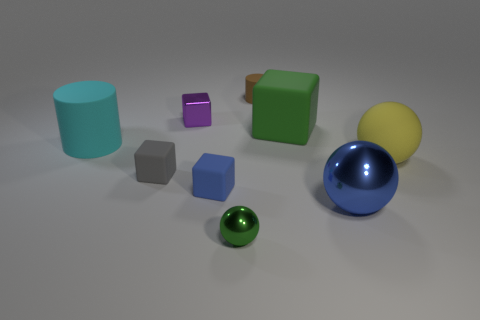Can you describe the arrangement and colors of the objects in the image? Certainly! The image depicts a collection of various geometric shapes arranged on a flat surface. Starting from the left, there is a teal cylinder, a small purple cube, a tiny gray matte block, a larger green cube, a reflective blue sphere, and a muted yellow sphere. A smaller green metallic sphere sits in front of the blue one. The objects are set against a neutral gray background, allowing their colors and shapes to stand out distinctly. 